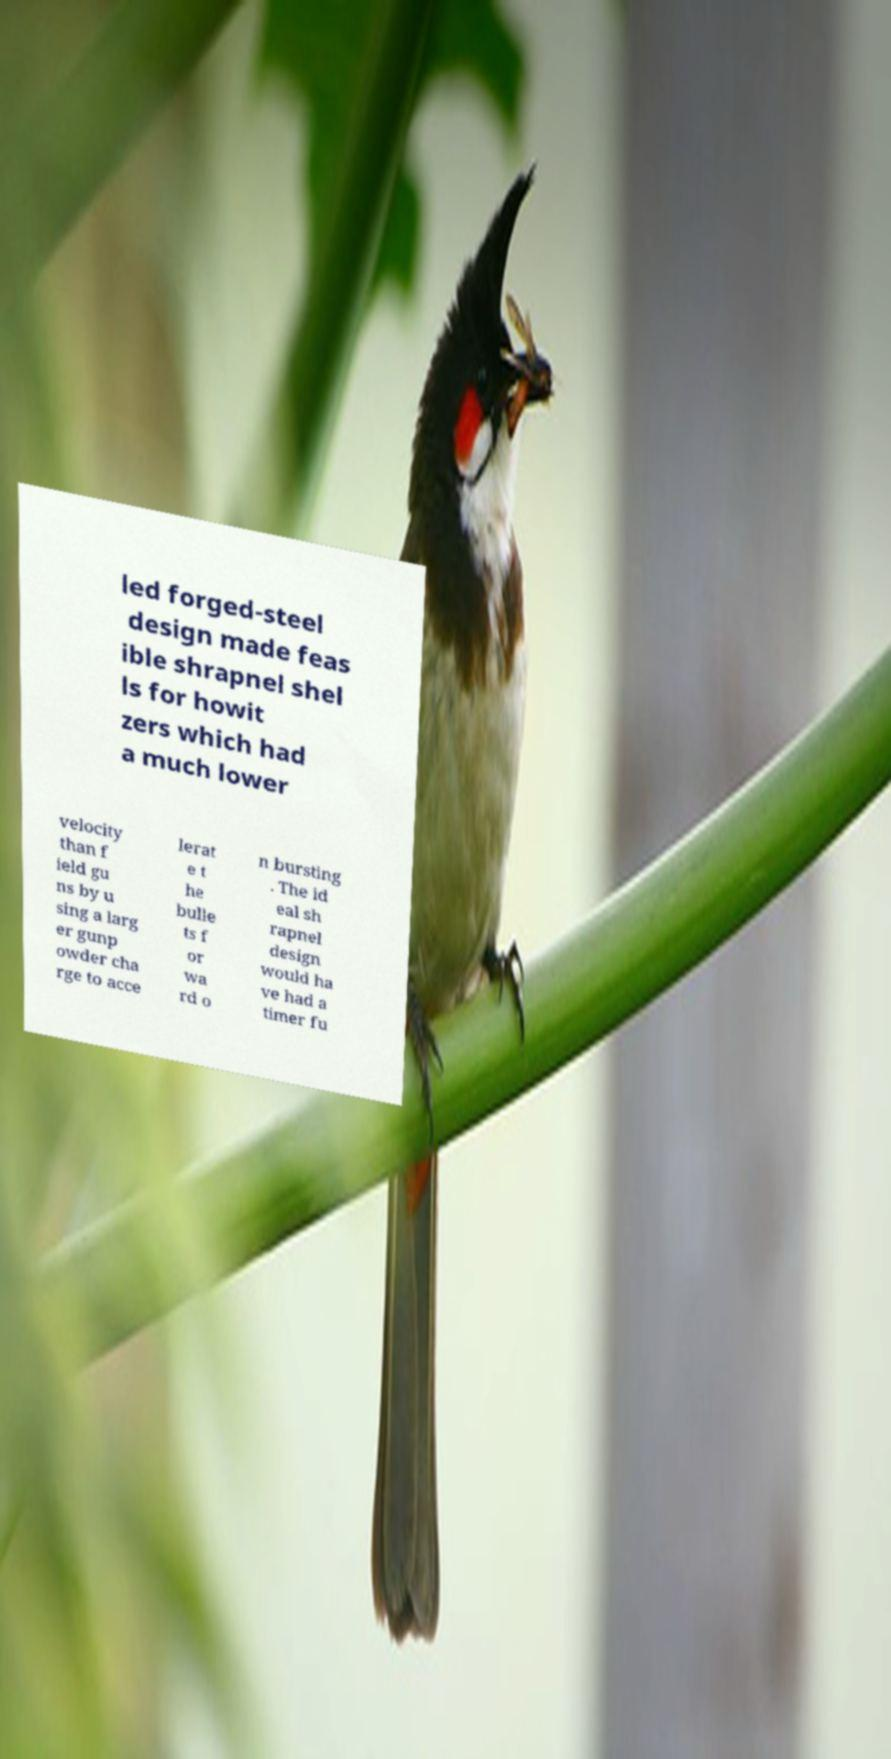Could you extract and type out the text from this image? led forged-steel design made feas ible shrapnel shel ls for howit zers which had a much lower velocity than f ield gu ns by u sing a larg er gunp owder cha rge to acce lerat e t he bulle ts f or wa rd o n bursting . The id eal sh rapnel design would ha ve had a timer fu 